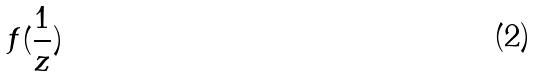Convert formula to latex. <formula><loc_0><loc_0><loc_500><loc_500>f ( \frac { 1 } { z } )</formula> 